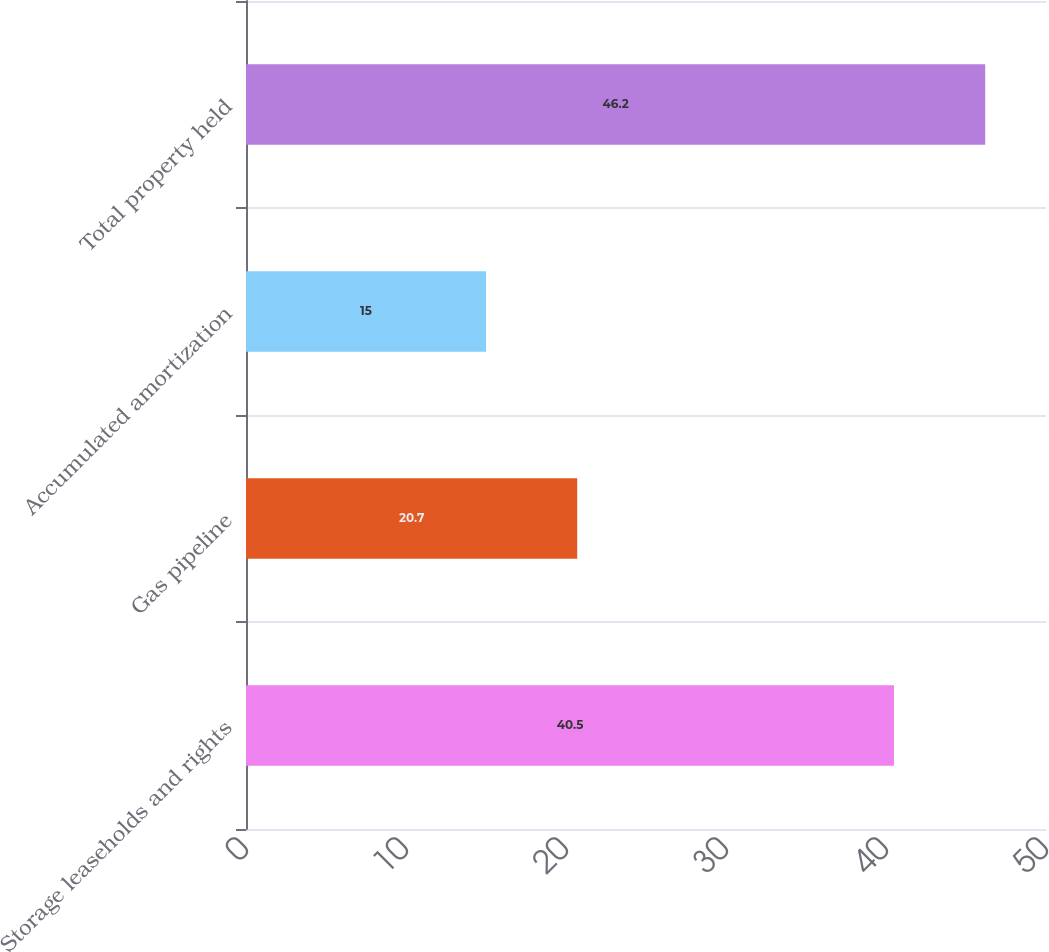<chart> <loc_0><loc_0><loc_500><loc_500><bar_chart><fcel>Storage leaseholds and rights<fcel>Gas pipeline<fcel>Accumulated amortization<fcel>Total property held<nl><fcel>40.5<fcel>20.7<fcel>15<fcel>46.2<nl></chart> 